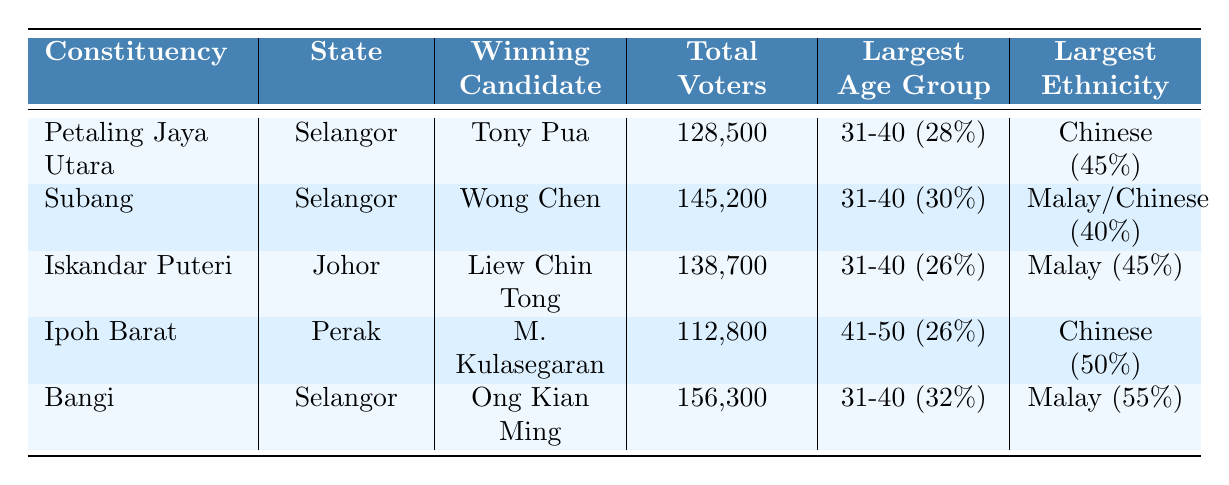What is the total number of voters in the Bangi constituency? The table shows that the total number of voters in Bangi is specifically mentioned as 156,300.
Answer: 156,300 Which constituency has the highest percentage of Malay voters? The data from the table indicates that Bangi has the highest percentage of Malay voters at 55%.
Answer: Bangi What is the largest age group in the Subang constituency? In the table, it shows that the largest age group in Subang is 31-40 years old, with a percentage of 30%.
Answer: 31-40 How many constituencies won by Pakatan Harapan have a majority of Chinese voters? By reviewing the table, Ipoh Barat has the majority of Chinese voters at 50%, while Petaling Jaya Utara and Subang both show significant percentages as well. However, only Ipoh Barat exceeds 50%. Therefore, there is only one constituency with a majority of Chinese voters.
Answer: 1 What is the average percentage of voters aged 60 and above across all constituencies? By summing the percentages of voters aged 60 and above from all constituencies ((10 + 8 + 11 + 12 + 6) = 47) and then dividing by the number of constituencies (5), we find the average is 47 / 5 = 9.4%.
Answer: 9.4% Is the total number of voters in Iskandar Puteri greater than that in Ipoh Barat? The table states that Iskandar Puteri has 138,700 voters and Ipoh Barat has 112,800. Since 138,700 is greater than 112,800, the statement is true.
Answer: Yes What is the overall percentage of tertiary-educated voters in these constituencies? Adding up the tertiary educated percentages from all constituencies (60 + 55 + 50 + 45 + 65 = 275) and dividing by the number of constituencies (5) gives us an average of 275 / 5 = 55%.
Answer: 55% Which candidate from Pakatan Harapan has the highest total voter support? Reviewing the total voters in each constituency, Bangi has the highest total voters at 156,300, which corresponds to the candidate Ong Kian Ming.
Answer: Ong Kian Ming Which two ethnic groups have a tie in the Subang constituency? In the table, both Malay and Chinese voters have an equal percentage of 40%, indicating they tie for the largest ethnic group in Subang.
Answer: Malay and Chinese What percentage of voters in Ipoh Barat have a secondary education? According to the table, Ipoh Barat has 45% of voters with a secondary education.
Answer: 45% 